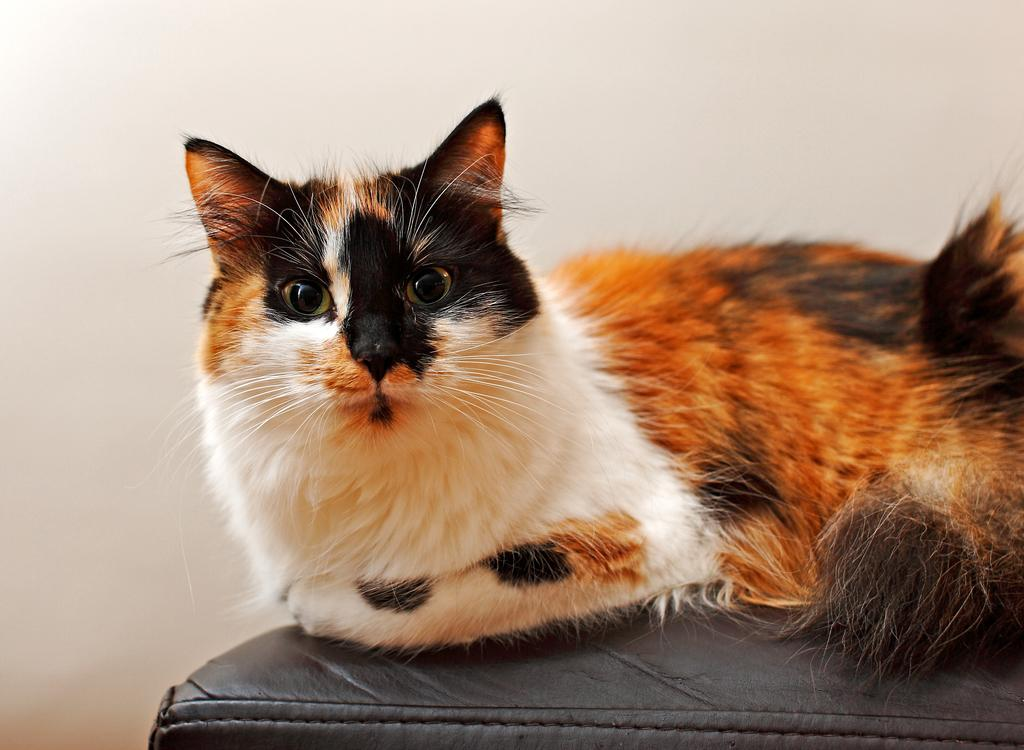What type of animal is in the image? There is a cat in the image. Where is the cat sitting? The cat is sitting on a black surface. What can be seen in the background of the image? There is a white wall in the background of the image. What type of square object can be seen in the image? There is no square object present in the image; it features a cat sitting on a black surface with a white wall in the background. 